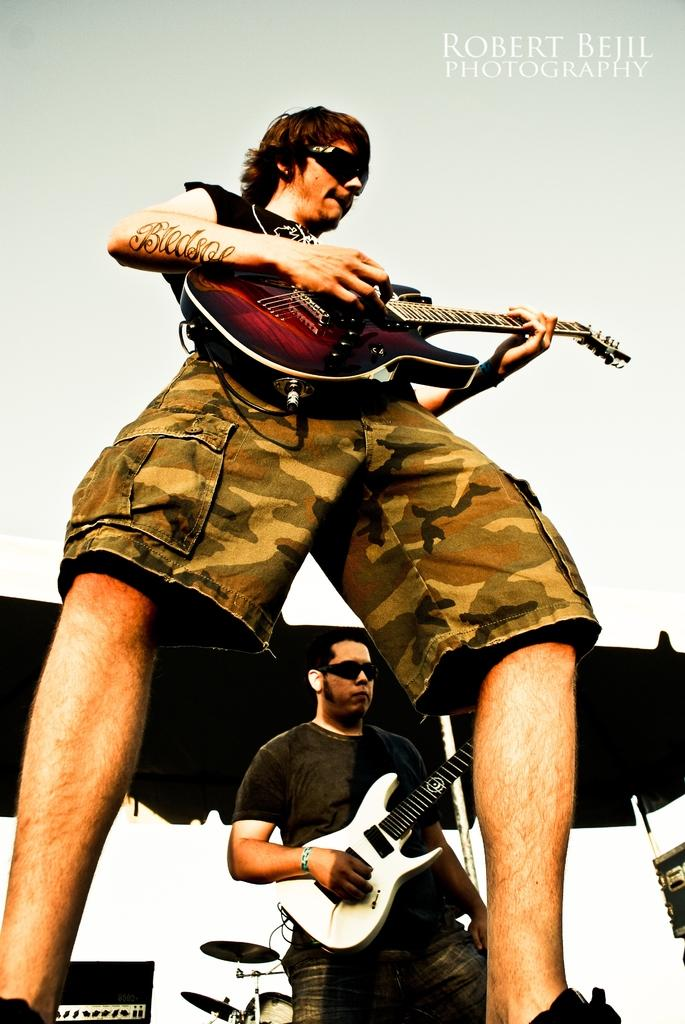What is the man in the image doing? The man is playing a guitar in the image. What type of object is the man using to play music? The man is using a guitar, which is a musical instrument. How many cherries are on the man's head in the image? There are no cherries present on the man's head in the image. What type of maid is assisting the man in the image? There is no maid present in the image. 